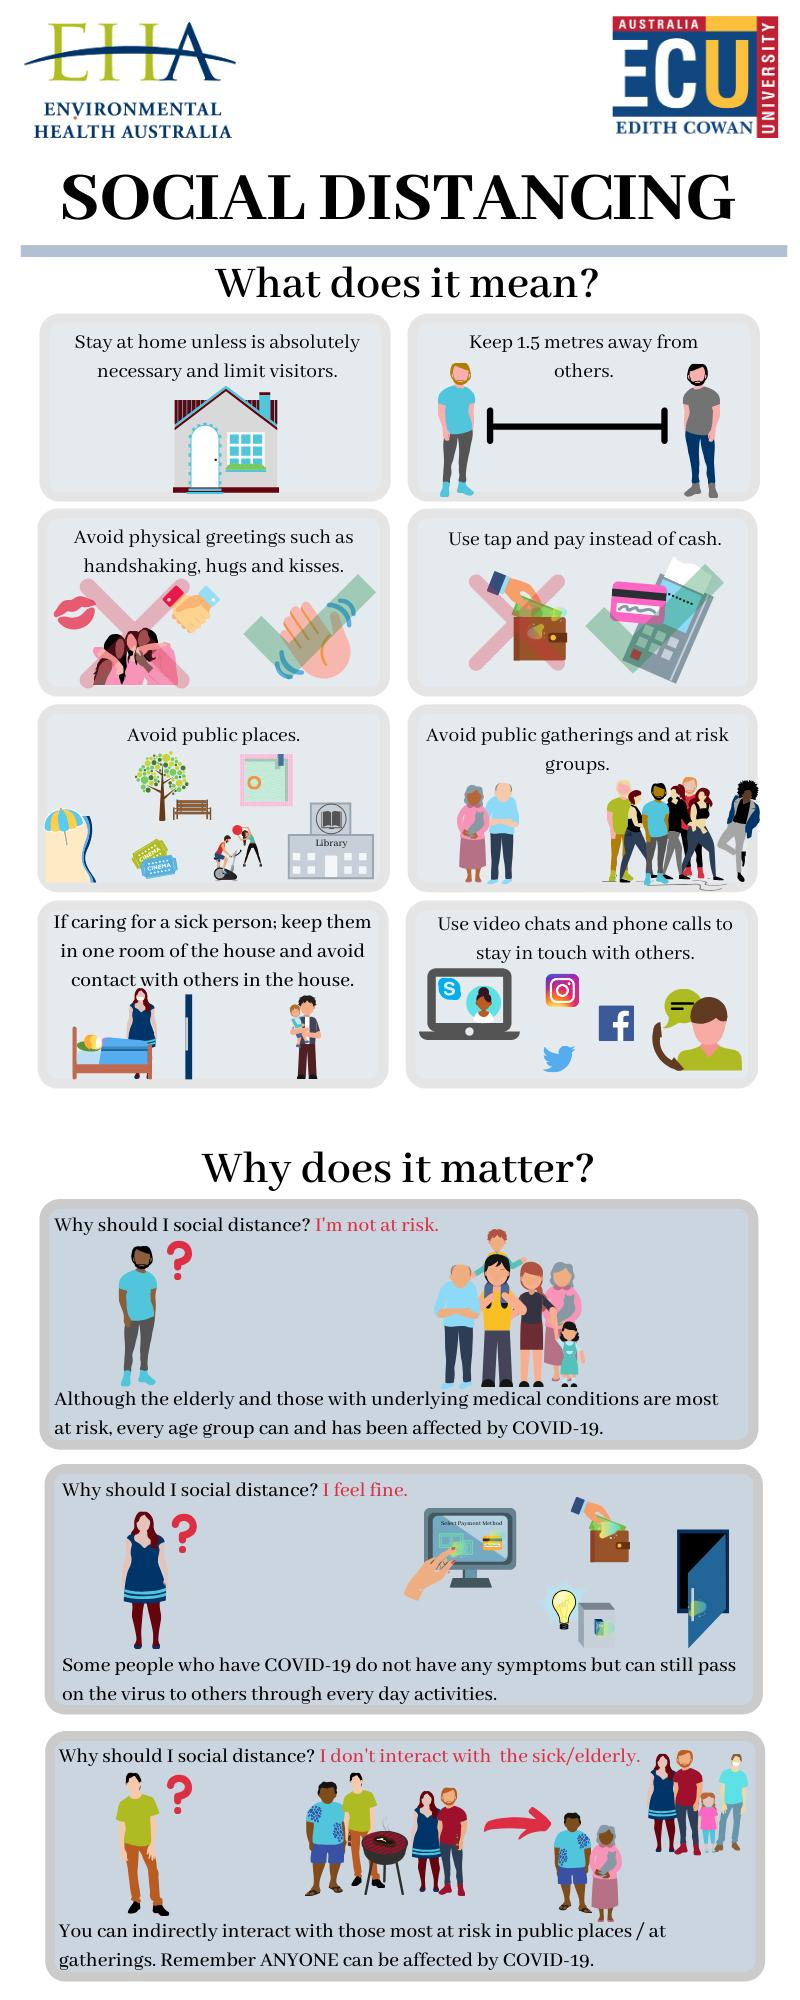Highlight a few significant elements in this photo. It is recommended to maintain a safe distance of 1.5 metres between individuals as a part of social distancing in order to reduce the risk of the spread of infectious diseases. 